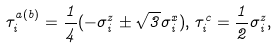<formula> <loc_0><loc_0><loc_500><loc_500>\tau _ { i } ^ { a ( b ) } = \frac { 1 } { 4 } ( - \sigma _ { i } ^ { z } \pm \sqrt { 3 } \sigma _ { i } ^ { x } ) , \, \tau _ { i } ^ { c } = \frac { 1 } { 2 } \sigma _ { i } ^ { z } ,</formula> 